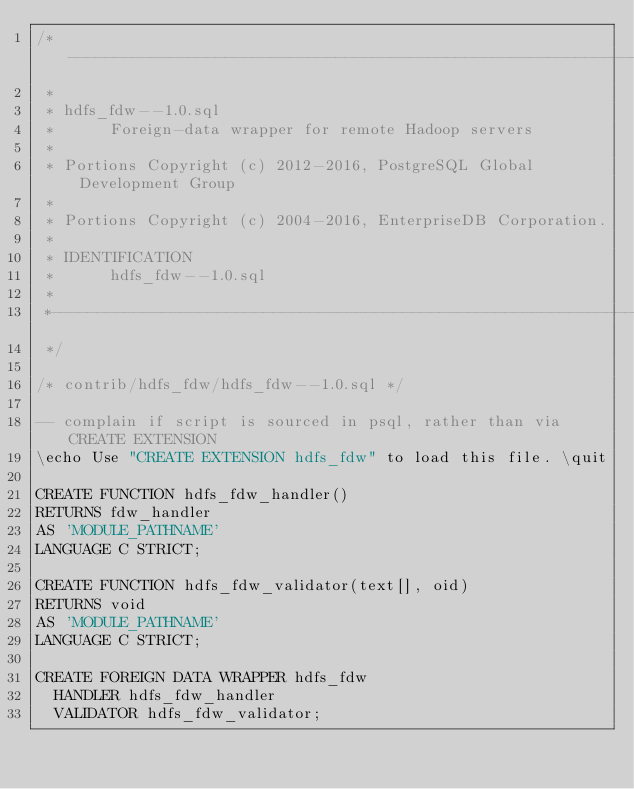Convert code to text. <code><loc_0><loc_0><loc_500><loc_500><_SQL_>/*-------------------------------------------------------------------------
 *
 * hdfs_fdw--1.0.sql
 * 		Foreign-data wrapper for remote Hadoop servers
 *
 * Portions Copyright (c) 2012-2016, PostgreSQL Global Development Group
 *
 * Portions Copyright (c) 2004-2016, EnterpriseDB Corporation.
 *
 * IDENTIFICATION
 * 		hdfs_fdw--1.0.sql
 *
 *-------------------------------------------------------------------------
 */

/* contrib/hdfs_fdw/hdfs_fdw--1.0.sql */

-- complain if script is sourced in psql, rather than via CREATE EXTENSION
\echo Use "CREATE EXTENSION hdfs_fdw" to load this file. \quit

CREATE FUNCTION hdfs_fdw_handler()
RETURNS fdw_handler
AS 'MODULE_PATHNAME'
LANGUAGE C STRICT;

CREATE FUNCTION hdfs_fdw_validator(text[], oid)
RETURNS void
AS 'MODULE_PATHNAME'
LANGUAGE C STRICT;

CREATE FOREIGN DATA WRAPPER hdfs_fdw
  HANDLER hdfs_fdw_handler
  VALIDATOR hdfs_fdw_validator;
</code> 